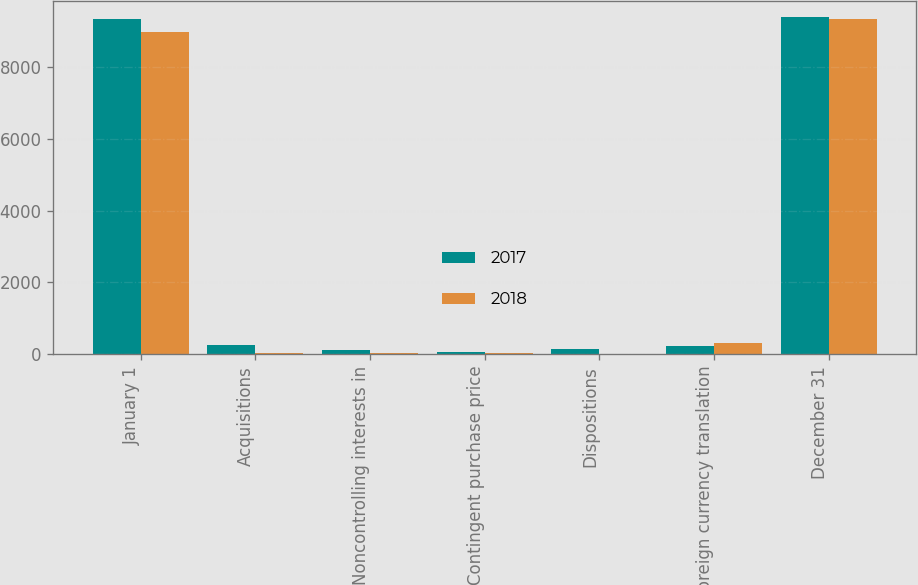Convert chart. <chart><loc_0><loc_0><loc_500><loc_500><stacked_bar_chart><ecel><fcel>January 1<fcel>Acquisitions<fcel>Noncontrolling interests in<fcel>Contingent purchase price<fcel>Dispositions<fcel>Foreign currency translation<fcel>December 31<nl><fcel>2017<fcel>9337.5<fcel>250.6<fcel>112<fcel>60<fcel>143.6<fcel>232.2<fcel>9384.3<nl><fcel>2018<fcel>8976.1<fcel>19.3<fcel>18.9<fcel>27.1<fcel>4.6<fcel>300.7<fcel>9337.5<nl></chart> 